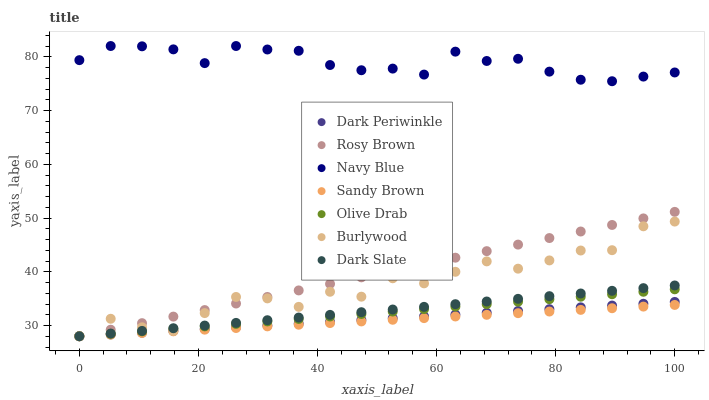Does Sandy Brown have the minimum area under the curve?
Answer yes or no. Yes. Does Navy Blue have the maximum area under the curve?
Answer yes or no. Yes. Does Rosy Brown have the minimum area under the curve?
Answer yes or no. No. Does Rosy Brown have the maximum area under the curve?
Answer yes or no. No. Is Sandy Brown the smoothest?
Answer yes or no. Yes. Is Burlywood the roughest?
Answer yes or no. Yes. Is Navy Blue the smoothest?
Answer yes or no. No. Is Navy Blue the roughest?
Answer yes or no. No. Does Burlywood have the lowest value?
Answer yes or no. Yes. Does Navy Blue have the lowest value?
Answer yes or no. No. Does Navy Blue have the highest value?
Answer yes or no. Yes. Does Rosy Brown have the highest value?
Answer yes or no. No. Is Dark Slate less than Navy Blue?
Answer yes or no. Yes. Is Navy Blue greater than Sandy Brown?
Answer yes or no. Yes. Does Olive Drab intersect Dark Periwinkle?
Answer yes or no. Yes. Is Olive Drab less than Dark Periwinkle?
Answer yes or no. No. Is Olive Drab greater than Dark Periwinkle?
Answer yes or no. No. Does Dark Slate intersect Navy Blue?
Answer yes or no. No. 